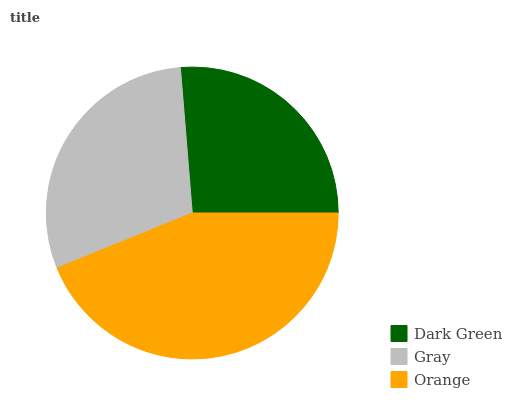Is Dark Green the minimum?
Answer yes or no. Yes. Is Orange the maximum?
Answer yes or no. Yes. Is Gray the minimum?
Answer yes or no. No. Is Gray the maximum?
Answer yes or no. No. Is Gray greater than Dark Green?
Answer yes or no. Yes. Is Dark Green less than Gray?
Answer yes or no. Yes. Is Dark Green greater than Gray?
Answer yes or no. No. Is Gray less than Dark Green?
Answer yes or no. No. Is Gray the high median?
Answer yes or no. Yes. Is Gray the low median?
Answer yes or no. Yes. Is Orange the high median?
Answer yes or no. No. Is Dark Green the low median?
Answer yes or no. No. 